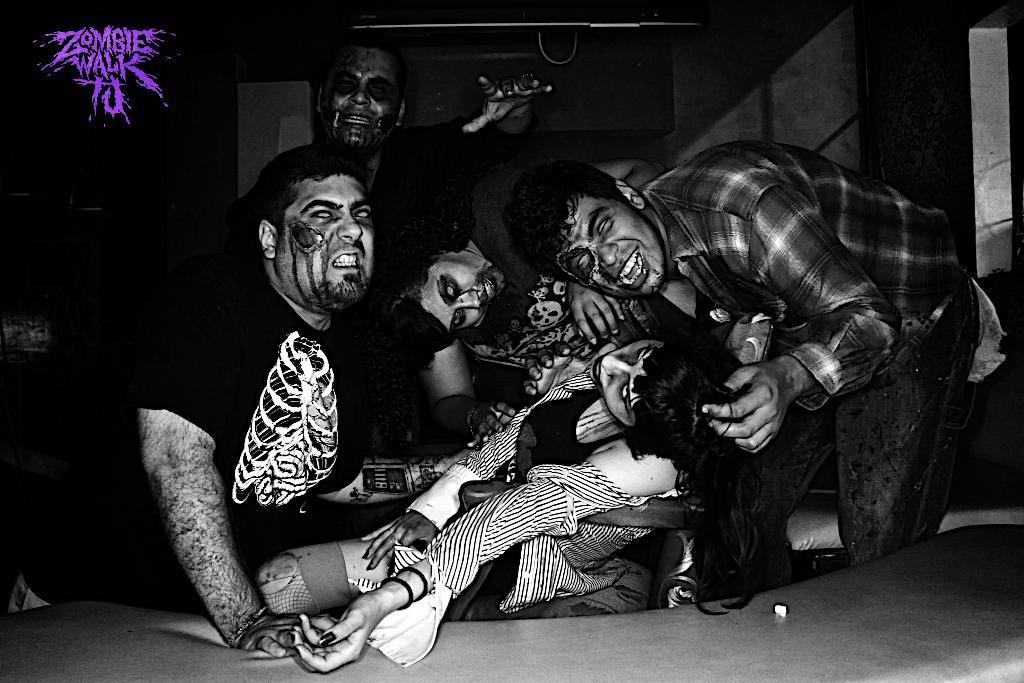Describe this image in one or two sentences. In this image there are a few people dressed as zombies are posing for the camera. 